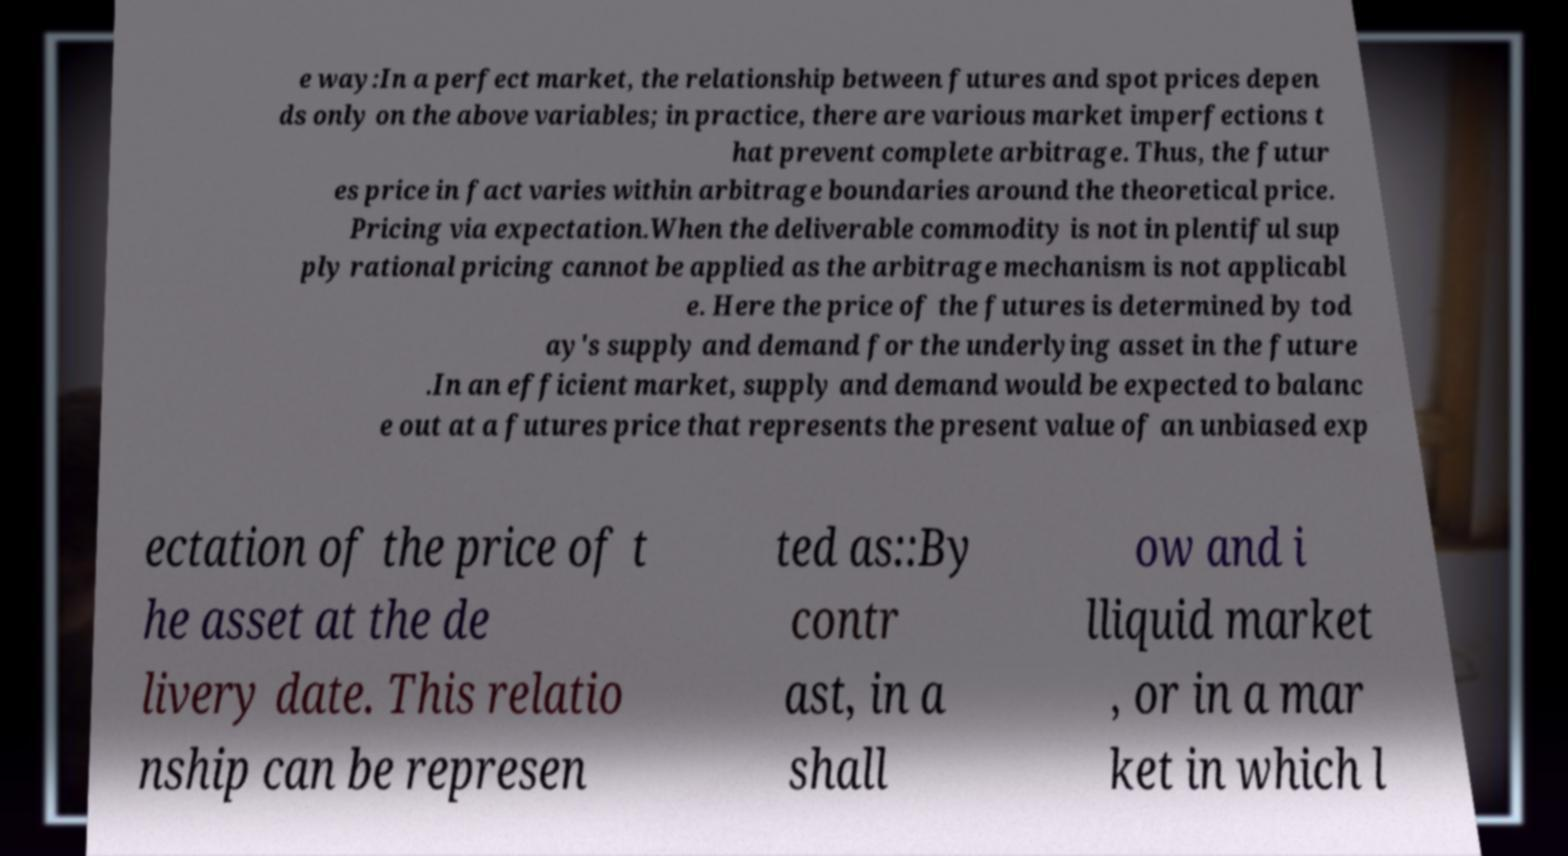Please identify and transcribe the text found in this image. e way:In a perfect market, the relationship between futures and spot prices depen ds only on the above variables; in practice, there are various market imperfections t hat prevent complete arbitrage. Thus, the futur es price in fact varies within arbitrage boundaries around the theoretical price. Pricing via expectation.When the deliverable commodity is not in plentiful sup ply rational pricing cannot be applied as the arbitrage mechanism is not applicabl e. Here the price of the futures is determined by tod ay's supply and demand for the underlying asset in the future .In an efficient market, supply and demand would be expected to balanc e out at a futures price that represents the present value of an unbiased exp ectation of the price of t he asset at the de livery date. This relatio nship can be represen ted as::By contr ast, in a shall ow and i lliquid market , or in a mar ket in which l 